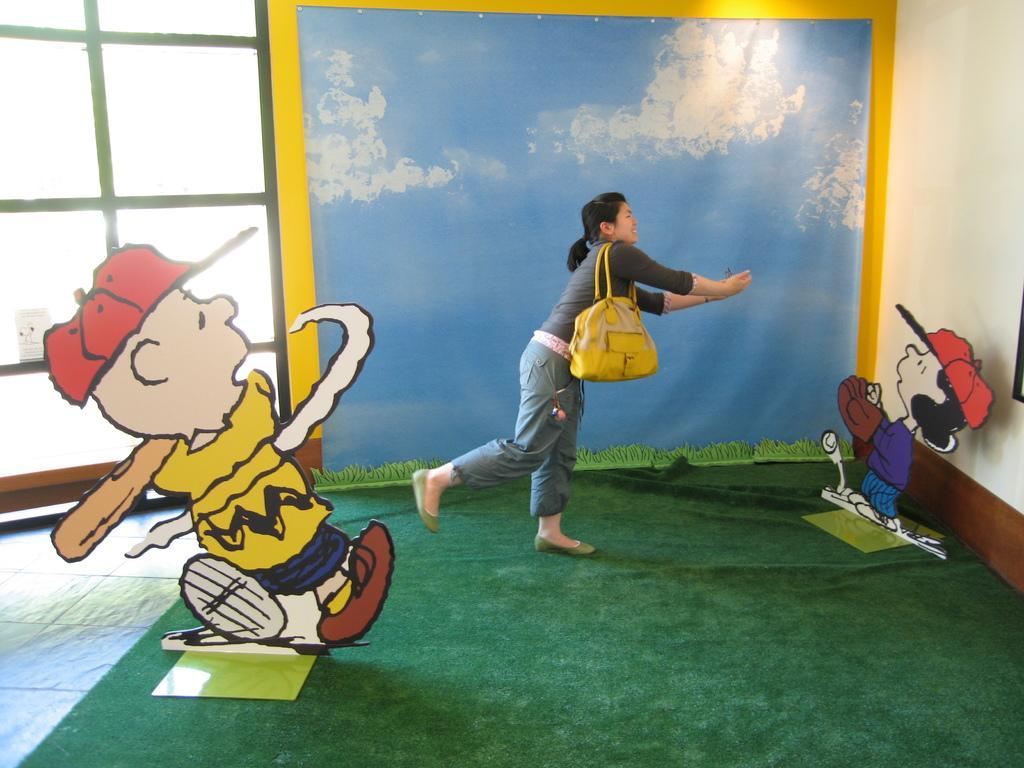Could you give a brief overview of what you see in this image? This image is clicked in a room. There are two cartoons on the right side and left side. There is a woman in the middle. She is the hanging a bag to her hands it is in yellow color. 